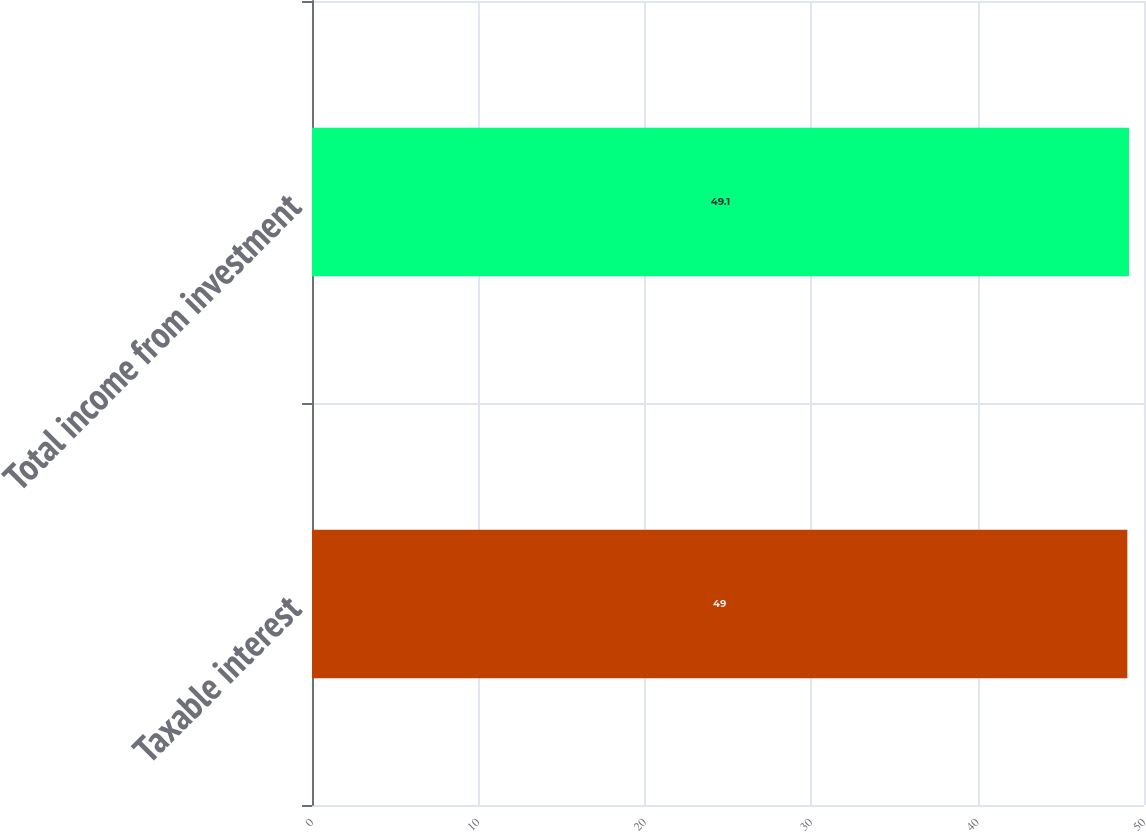<chart> <loc_0><loc_0><loc_500><loc_500><bar_chart><fcel>Taxable interest<fcel>Total income from investment<nl><fcel>49<fcel>49.1<nl></chart> 